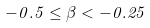Convert formula to latex. <formula><loc_0><loc_0><loc_500><loc_500>- 0 . 5 \leq \beta < - 0 . 2 5</formula> 